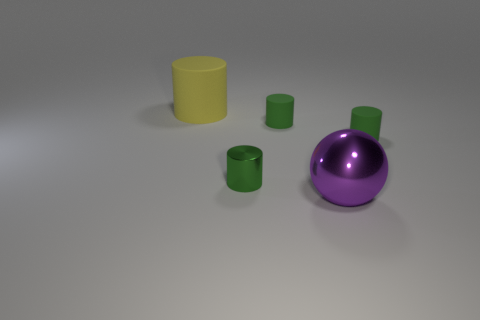How many tiny matte things are the same color as the small shiny object?
Ensure brevity in your answer.  2. How many things are matte cylinders to the right of the big yellow matte thing or objects on the left side of the small metal thing?
Your answer should be compact. 3. Is the number of big yellow objects in front of the large yellow cylinder less than the number of tiny green metal objects?
Provide a succinct answer. Yes. Are there any green metallic things that have the same size as the green metallic cylinder?
Provide a short and direct response. No. What is the color of the large metal sphere?
Ensure brevity in your answer.  Purple. Is the yellow rubber cylinder the same size as the sphere?
Provide a succinct answer. Yes. What number of things are either cyan rubber cubes or big yellow rubber cylinders?
Offer a terse response. 1. Are there an equal number of green metal objects that are behind the big matte cylinder and large purple spheres?
Your response must be concise. No. Are there any metal objects that are in front of the big object to the right of the object on the left side of the small metal cylinder?
Offer a very short reply. No. There is another small object that is the same material as the purple object; what color is it?
Give a very brief answer. Green. 